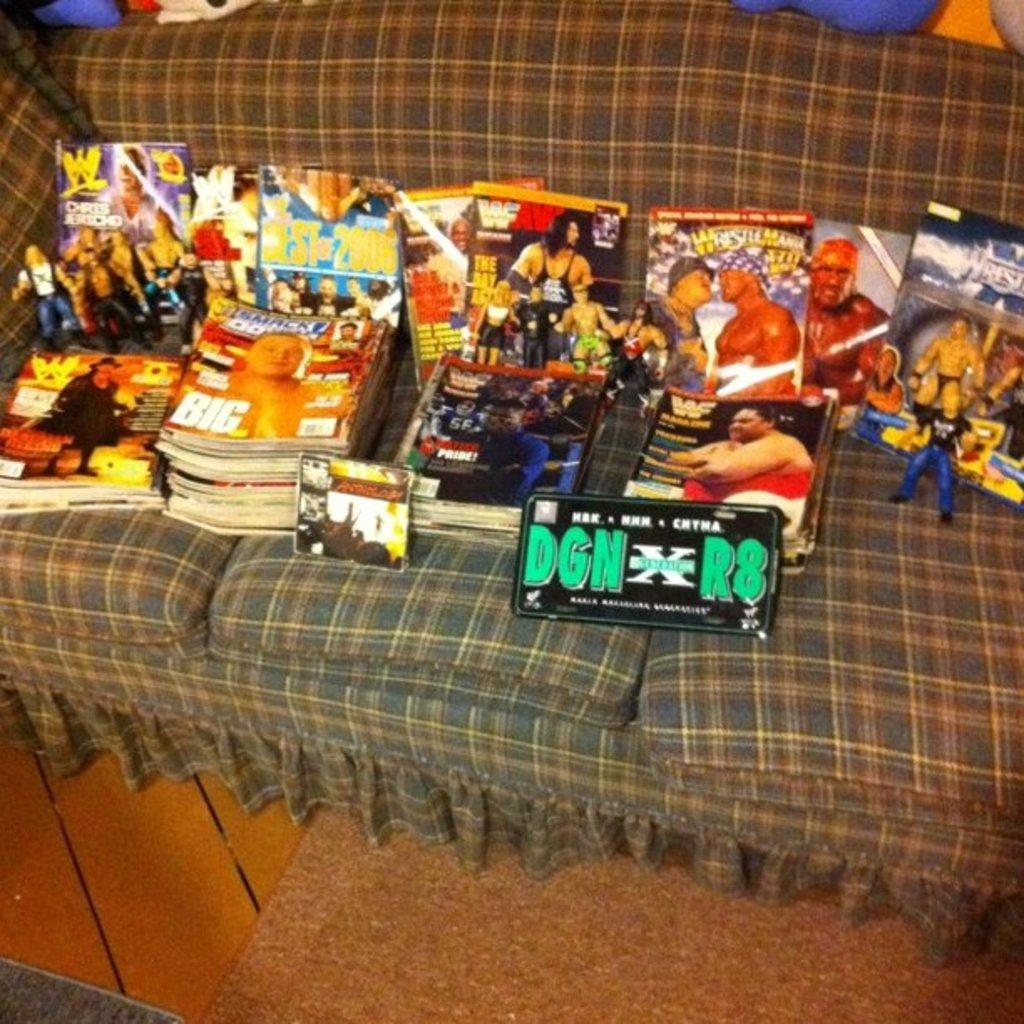What type of items can be seen in the image? There are books and other objects in the image. Where are the books and objects located? The books and objects are placed on a sofa. How many cherries are on the sofa in the image? There are no cherries present in the image. What is the angle of the sofa in the image? The angle of the sofa cannot be determined from the image, as it is not provided in the facts. 